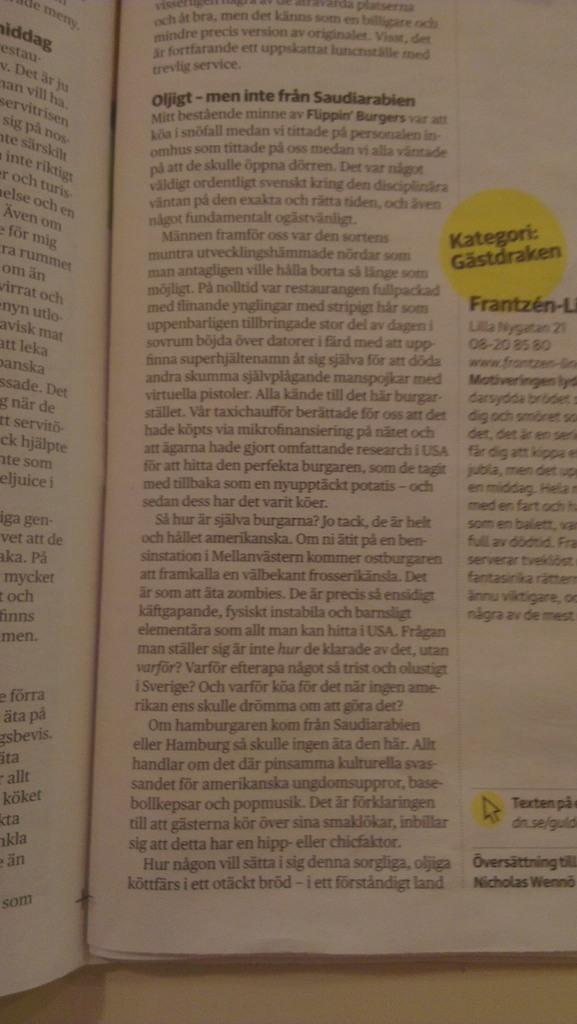<image>
Relay a brief, clear account of the picture shown. A textbook open to a page titled Kategori: Gastdraken. 